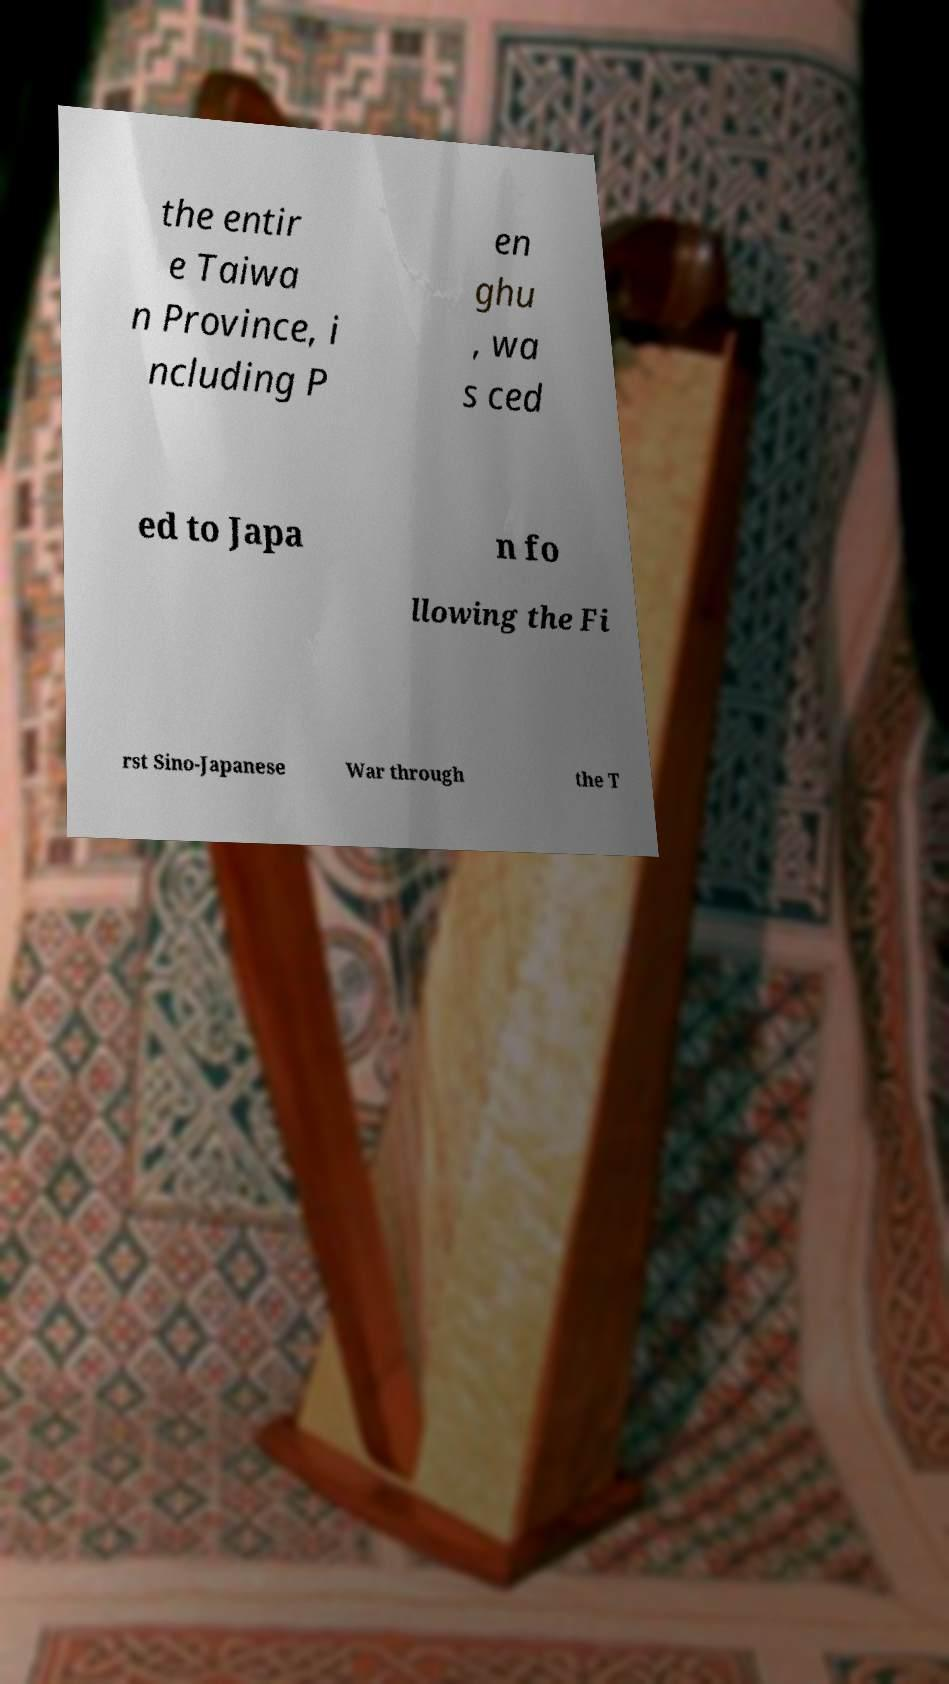What messages or text are displayed in this image? I need them in a readable, typed format. the entir e Taiwa n Province, i ncluding P en ghu , wa s ced ed to Japa n fo llowing the Fi rst Sino-Japanese War through the T 